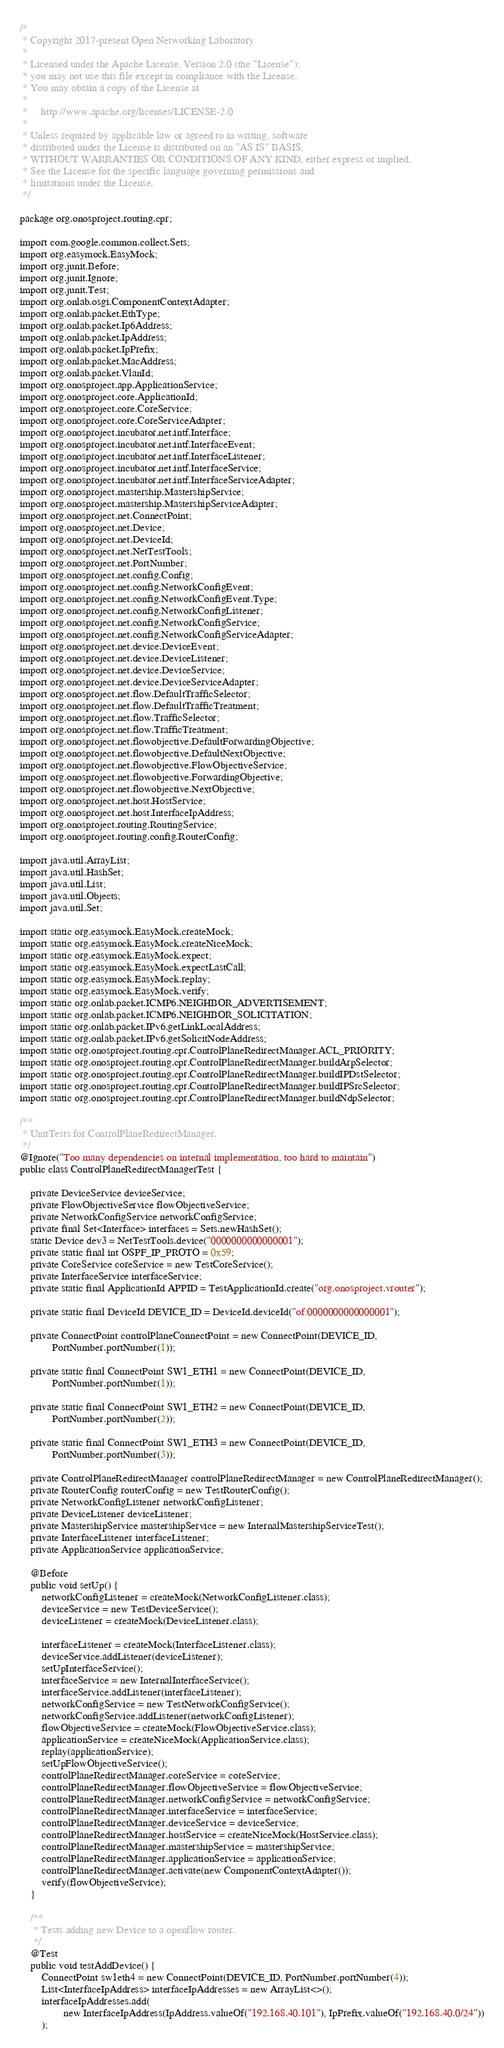<code> <loc_0><loc_0><loc_500><loc_500><_Java_>/*
 * Copyright 2017-present Open Networking Laboratory
 *
 * Licensed under the Apache License, Version 2.0 (the "License");
 * you may not use this file except in compliance with the License.
 * You may obtain a copy of the License at
 *
 *     http://www.apache.org/licenses/LICENSE-2.0
 *
 * Unless required by applicable law or agreed to in writing, software
 * distributed under the License is distributed on an "AS IS" BASIS,
 * WITHOUT WARRANTIES OR CONDITIONS OF ANY KIND, either express or implied.
 * See the License for the specific language governing permissions and
 * limitations under the License.
 */

package org.onosproject.routing.cpr;

import com.google.common.collect.Sets;
import org.easymock.EasyMock;
import org.junit.Before;
import org.junit.Ignore;
import org.junit.Test;
import org.onlab.osgi.ComponentContextAdapter;
import org.onlab.packet.EthType;
import org.onlab.packet.Ip6Address;
import org.onlab.packet.IpAddress;
import org.onlab.packet.IpPrefix;
import org.onlab.packet.MacAddress;
import org.onlab.packet.VlanId;
import org.onosproject.app.ApplicationService;
import org.onosproject.core.ApplicationId;
import org.onosproject.core.CoreService;
import org.onosproject.core.CoreServiceAdapter;
import org.onosproject.incubator.net.intf.Interface;
import org.onosproject.incubator.net.intf.InterfaceEvent;
import org.onosproject.incubator.net.intf.InterfaceListener;
import org.onosproject.incubator.net.intf.InterfaceService;
import org.onosproject.incubator.net.intf.InterfaceServiceAdapter;
import org.onosproject.mastership.MastershipService;
import org.onosproject.mastership.MastershipServiceAdapter;
import org.onosproject.net.ConnectPoint;
import org.onosproject.net.Device;
import org.onosproject.net.DeviceId;
import org.onosproject.net.NetTestTools;
import org.onosproject.net.PortNumber;
import org.onosproject.net.config.Config;
import org.onosproject.net.config.NetworkConfigEvent;
import org.onosproject.net.config.NetworkConfigEvent.Type;
import org.onosproject.net.config.NetworkConfigListener;
import org.onosproject.net.config.NetworkConfigService;
import org.onosproject.net.config.NetworkConfigServiceAdapter;
import org.onosproject.net.device.DeviceEvent;
import org.onosproject.net.device.DeviceListener;
import org.onosproject.net.device.DeviceService;
import org.onosproject.net.device.DeviceServiceAdapter;
import org.onosproject.net.flow.DefaultTrafficSelector;
import org.onosproject.net.flow.DefaultTrafficTreatment;
import org.onosproject.net.flow.TrafficSelector;
import org.onosproject.net.flow.TrafficTreatment;
import org.onosproject.net.flowobjective.DefaultForwardingObjective;
import org.onosproject.net.flowobjective.DefaultNextObjective;
import org.onosproject.net.flowobjective.FlowObjectiveService;
import org.onosproject.net.flowobjective.ForwardingObjective;
import org.onosproject.net.flowobjective.NextObjective;
import org.onosproject.net.host.HostService;
import org.onosproject.net.host.InterfaceIpAddress;
import org.onosproject.routing.RoutingService;
import org.onosproject.routing.config.RouterConfig;

import java.util.ArrayList;
import java.util.HashSet;
import java.util.List;
import java.util.Objects;
import java.util.Set;

import static org.easymock.EasyMock.createMock;
import static org.easymock.EasyMock.createNiceMock;
import static org.easymock.EasyMock.expect;
import static org.easymock.EasyMock.expectLastCall;
import static org.easymock.EasyMock.replay;
import static org.easymock.EasyMock.verify;
import static org.onlab.packet.ICMP6.NEIGHBOR_ADVERTISEMENT;
import static org.onlab.packet.ICMP6.NEIGHBOR_SOLICITATION;
import static org.onlab.packet.IPv6.getLinkLocalAddress;
import static org.onlab.packet.IPv6.getSolicitNodeAddress;
import static org.onosproject.routing.cpr.ControlPlaneRedirectManager.ACL_PRIORITY;
import static org.onosproject.routing.cpr.ControlPlaneRedirectManager.buildArpSelector;
import static org.onosproject.routing.cpr.ControlPlaneRedirectManager.buildIPDstSelector;
import static org.onosproject.routing.cpr.ControlPlaneRedirectManager.buildIPSrcSelector;
import static org.onosproject.routing.cpr.ControlPlaneRedirectManager.buildNdpSelector;

/**
 * UnitTests for ControlPlaneRedirectManager.
 */
@Ignore("Too many dependencies on internal implementation, too hard to maintain")
public class ControlPlaneRedirectManagerTest {

    private DeviceService deviceService;
    private FlowObjectiveService flowObjectiveService;
    private NetworkConfigService networkConfigService;
    private final Set<Interface> interfaces = Sets.newHashSet();
    static Device dev3 = NetTestTools.device("0000000000000001");
    private static final int OSPF_IP_PROTO = 0x59;
    private CoreService coreService = new TestCoreService();
    private InterfaceService interfaceService;
    private static final ApplicationId APPID = TestApplicationId.create("org.onosproject.vrouter");

    private static final DeviceId DEVICE_ID = DeviceId.deviceId("of:0000000000000001");

    private ConnectPoint controlPlaneConnectPoint = new ConnectPoint(DEVICE_ID,
            PortNumber.portNumber(1));

    private static final ConnectPoint SW1_ETH1 = new ConnectPoint(DEVICE_ID,
            PortNumber.portNumber(1));

    private static final ConnectPoint SW1_ETH2 = new ConnectPoint(DEVICE_ID,
            PortNumber.portNumber(2));

    private static final ConnectPoint SW1_ETH3 = new ConnectPoint(DEVICE_ID,
            PortNumber.portNumber(3));

    private ControlPlaneRedirectManager controlPlaneRedirectManager = new ControlPlaneRedirectManager();
    private RouterConfig routerConfig = new TestRouterConfig();
    private NetworkConfigListener networkConfigListener;
    private DeviceListener deviceListener;
    private MastershipService mastershipService = new InternalMastershipServiceTest();
    private InterfaceListener interfaceListener;
    private ApplicationService applicationService;

    @Before
    public void setUp() {
        networkConfigListener = createMock(NetworkConfigListener.class);
        deviceService = new TestDeviceService();
        deviceListener = createMock(DeviceListener.class);

        interfaceListener = createMock(InterfaceListener.class);
        deviceService.addListener(deviceListener);
        setUpInterfaceService();
        interfaceService = new InternalInterfaceService();
        interfaceService.addListener(interfaceListener);
        networkConfigService = new TestNetworkConfigService();
        networkConfigService.addListener(networkConfigListener);
        flowObjectiveService = createMock(FlowObjectiveService.class);
        applicationService = createNiceMock(ApplicationService.class);
        replay(applicationService);
        setUpFlowObjectiveService();
        controlPlaneRedirectManager.coreService = coreService;
        controlPlaneRedirectManager.flowObjectiveService = flowObjectiveService;
        controlPlaneRedirectManager.networkConfigService = networkConfigService;
        controlPlaneRedirectManager.interfaceService = interfaceService;
        controlPlaneRedirectManager.deviceService = deviceService;
        controlPlaneRedirectManager.hostService = createNiceMock(HostService.class);
        controlPlaneRedirectManager.mastershipService = mastershipService;
        controlPlaneRedirectManager.applicationService = applicationService;
        controlPlaneRedirectManager.activate(new ComponentContextAdapter());
        verify(flowObjectiveService);
    }

    /**
     * Tests adding new Device to a openflow router.
     */
    @Test
    public void testAddDevice() {
        ConnectPoint sw1eth4 = new ConnectPoint(DEVICE_ID, PortNumber.portNumber(4));
        List<InterfaceIpAddress> interfaceIpAddresses = new ArrayList<>();
        interfaceIpAddresses.add(
                new InterfaceIpAddress(IpAddress.valueOf("192.168.40.101"), IpPrefix.valueOf("192.168.40.0/24"))
        );</code> 